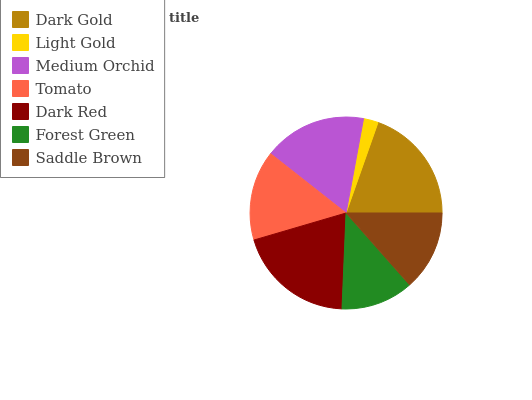Is Light Gold the minimum?
Answer yes or no. Yes. Is Dark Red the maximum?
Answer yes or no. Yes. Is Medium Orchid the minimum?
Answer yes or no. No. Is Medium Orchid the maximum?
Answer yes or no. No. Is Medium Orchid greater than Light Gold?
Answer yes or no. Yes. Is Light Gold less than Medium Orchid?
Answer yes or no. Yes. Is Light Gold greater than Medium Orchid?
Answer yes or no. No. Is Medium Orchid less than Light Gold?
Answer yes or no. No. Is Tomato the high median?
Answer yes or no. Yes. Is Tomato the low median?
Answer yes or no. Yes. Is Medium Orchid the high median?
Answer yes or no. No. Is Forest Green the low median?
Answer yes or no. No. 